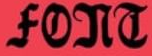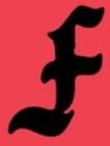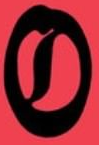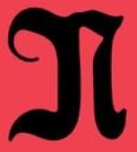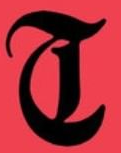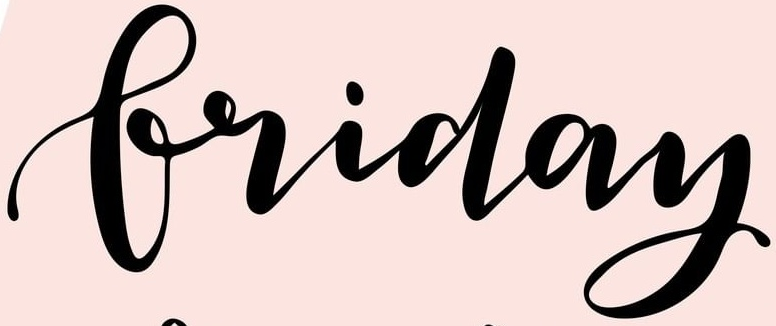Read the text content from these images in order, separated by a semicolon. FONT; F; O; N; T; Friday 